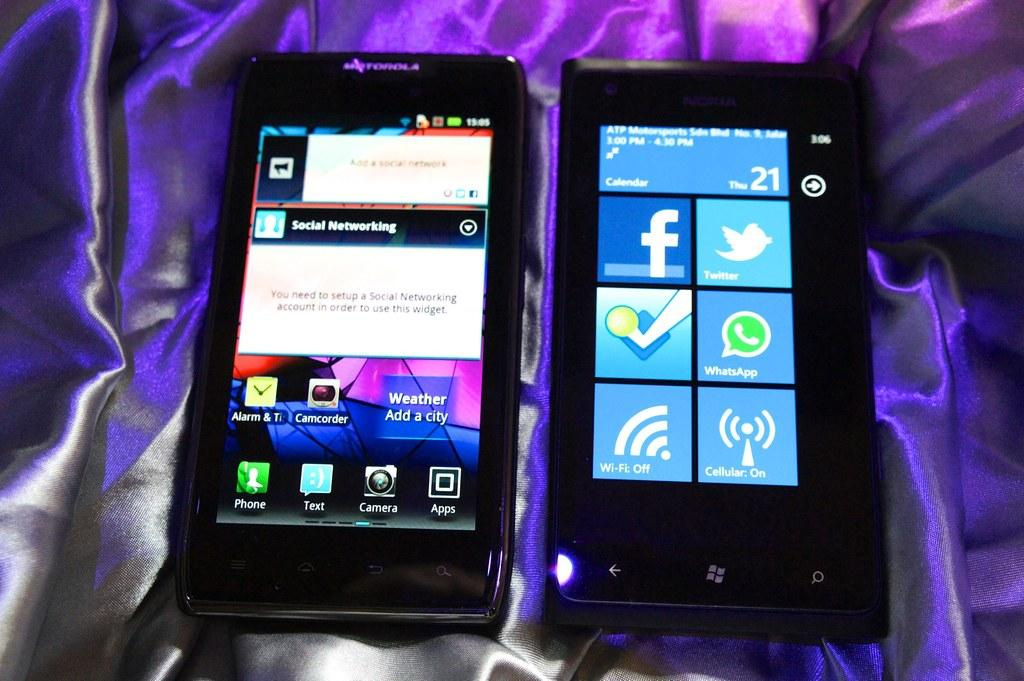<image>
Render a clear and concise summary of the photo. Two phones on a silk sheet one has Facebook ans Twitter on the screen. 